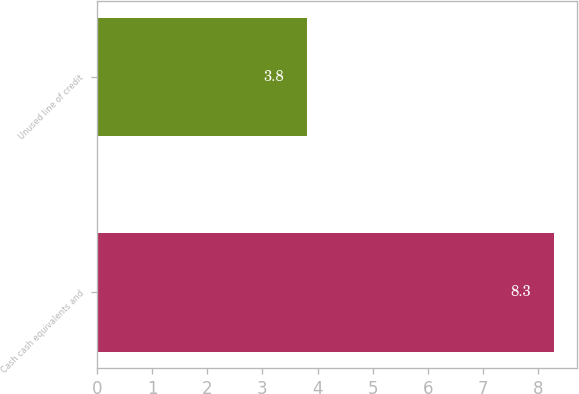Convert chart to OTSL. <chart><loc_0><loc_0><loc_500><loc_500><bar_chart><fcel>Cash cash equivalents and<fcel>Unused line of credit<nl><fcel>8.3<fcel>3.8<nl></chart> 